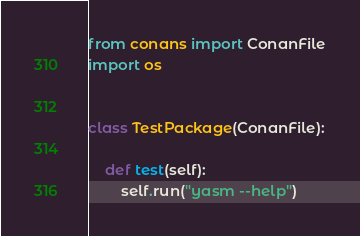Convert code to text. <code><loc_0><loc_0><loc_500><loc_500><_Python_>from conans import ConanFile
import os


class TestPackage(ConanFile):

    def test(self):
        self.run("yasm --help")
</code> 